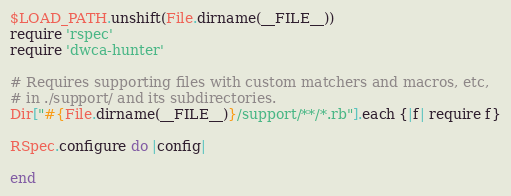Convert code to text. <code><loc_0><loc_0><loc_500><loc_500><_Ruby_>$LOAD_PATH.unshift(File.dirname(__FILE__))
require 'rspec'
require 'dwca-hunter'

# Requires supporting files with custom matchers and macros, etc,
# in ./support/ and its subdirectories.
Dir["#{File.dirname(__FILE__)}/support/**/*.rb"].each {|f| require f}

RSpec.configure do |config|
  
end
</code> 